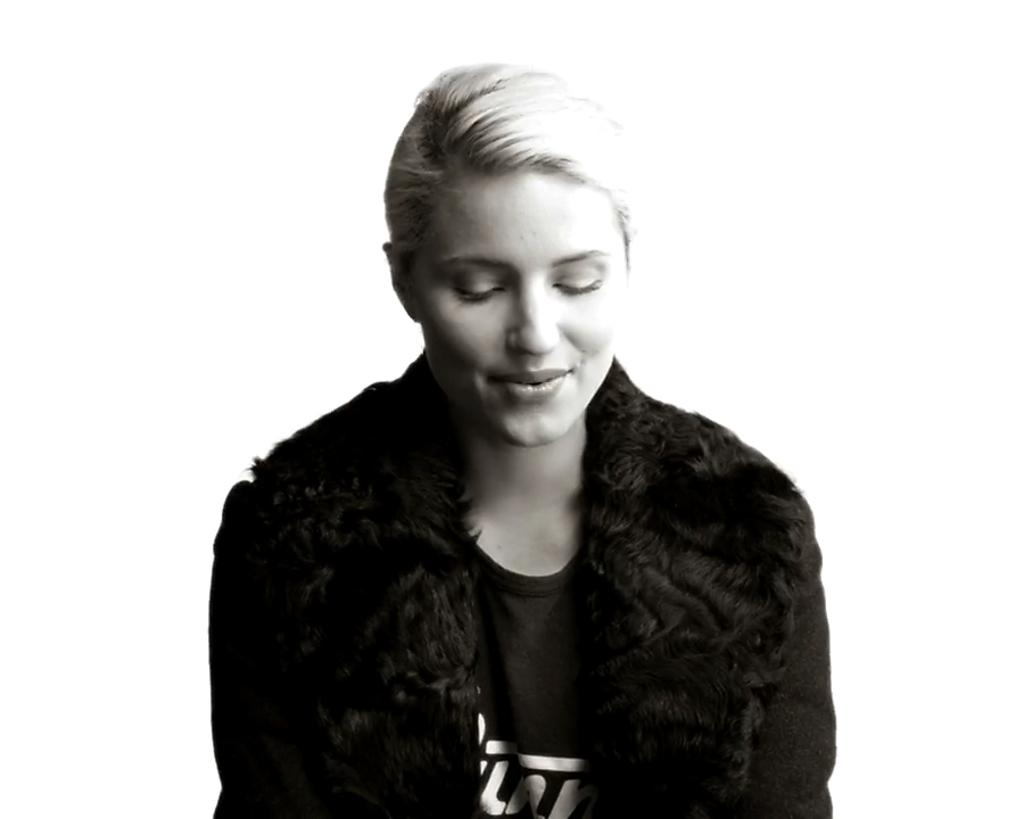Who is the main subject in the image? There is a woman in the image. Where is the woman located in the image? The woman is sitting in the center of the image. What is the woman's facial expression in the image? The woman is smiling in the image. What color is the jacket the woman is wearing? The woman is wearing a black color jacket. What type of receipt can be seen in the woman's hand in the image? There is no receipt present in the image; the woman's hands are not visible. What kind of spark can be seen coming from the woman's jacket in the image? There is no spark present in the image; the woman's jacket is not on fire or emitting any sparks. 